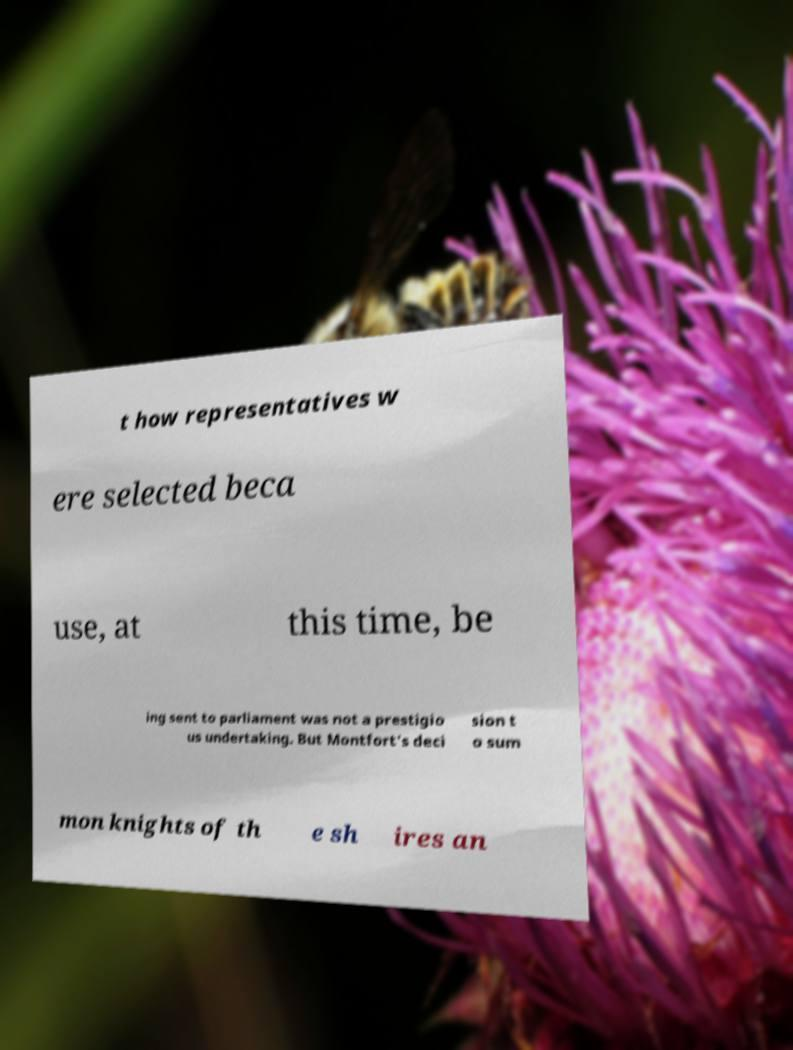Please identify and transcribe the text found in this image. t how representatives w ere selected beca use, at this time, be ing sent to parliament was not a prestigio us undertaking. But Montfort's deci sion t o sum mon knights of th e sh ires an 